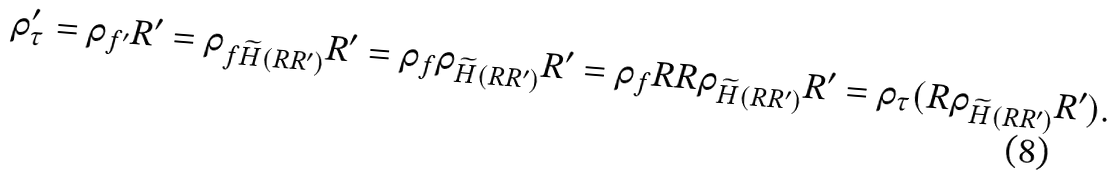<formula> <loc_0><loc_0><loc_500><loc_500>\rho ^ { \prime } _ { \tau } = \rho _ { f ^ { \prime } } R ^ { \prime } = \rho _ { f \widetilde { H } ( R R ^ { \prime } ) } R ^ { \prime } = \rho _ { f } \rho _ { \widetilde { H } ( R R ^ { \prime } ) } R ^ { \prime } = \rho _ { f } R R \rho _ { \widetilde { H } ( R R ^ { \prime } ) } R ^ { \prime } = \rho _ { \tau } ( R \rho _ { \widetilde { H } ( R R ^ { \prime } ) } R ^ { \prime } ) .</formula> 